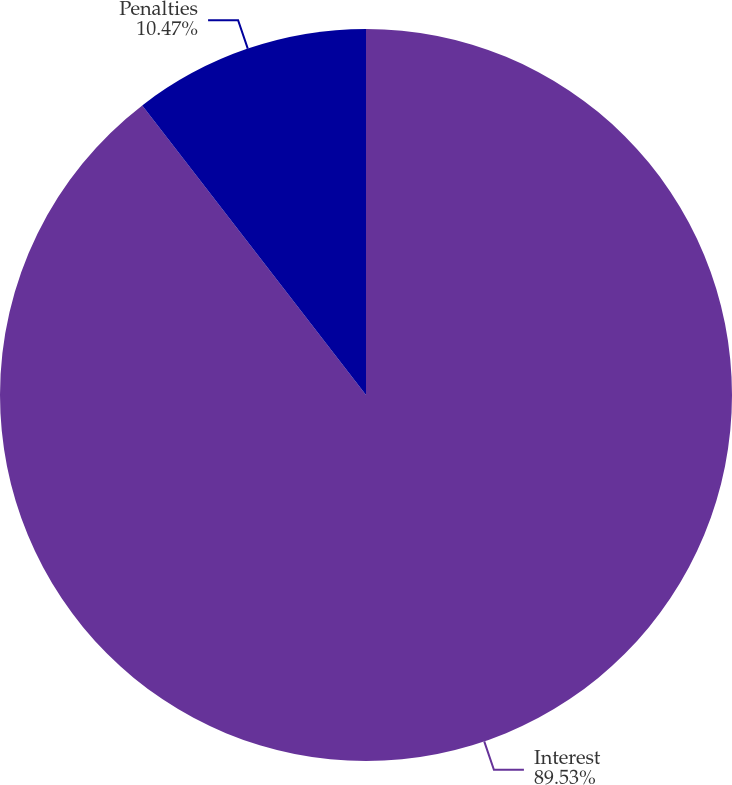Convert chart to OTSL. <chart><loc_0><loc_0><loc_500><loc_500><pie_chart><fcel>Interest<fcel>Penalties<nl><fcel>89.53%<fcel>10.47%<nl></chart> 